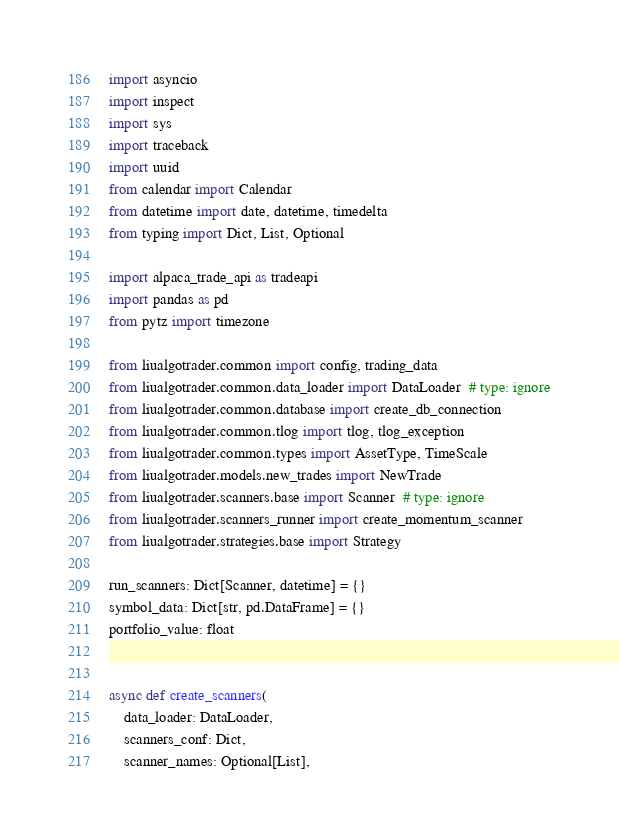<code> <loc_0><loc_0><loc_500><loc_500><_Python_>import asyncio
import inspect
import sys
import traceback
import uuid
from calendar import Calendar
from datetime import date, datetime, timedelta
from typing import Dict, List, Optional

import alpaca_trade_api as tradeapi
import pandas as pd
from pytz import timezone

from liualgotrader.common import config, trading_data
from liualgotrader.common.data_loader import DataLoader  # type: ignore
from liualgotrader.common.database import create_db_connection
from liualgotrader.common.tlog import tlog, tlog_exception
from liualgotrader.common.types import AssetType, TimeScale
from liualgotrader.models.new_trades import NewTrade
from liualgotrader.scanners.base import Scanner  # type: ignore
from liualgotrader.scanners_runner import create_momentum_scanner
from liualgotrader.strategies.base import Strategy

run_scanners: Dict[Scanner, datetime] = {}
symbol_data: Dict[str, pd.DataFrame] = {}
portfolio_value: float


async def create_scanners(
    data_loader: DataLoader,
    scanners_conf: Dict,
    scanner_names: Optional[List],</code> 